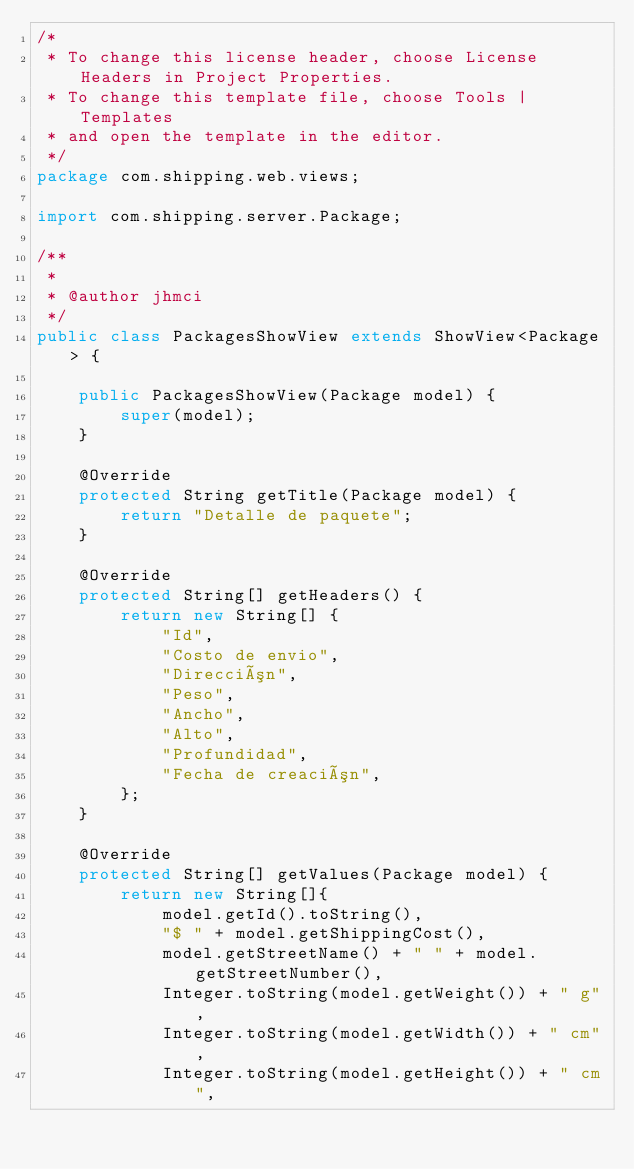<code> <loc_0><loc_0><loc_500><loc_500><_Java_>/*
 * To change this license header, choose License Headers in Project Properties.
 * To change this template file, choose Tools | Templates
 * and open the template in the editor.
 */
package com.shipping.web.views;

import com.shipping.server.Package; 

/**
 *
 * @author jhmci
 */
public class PackagesShowView extends ShowView<Package> {

    public PackagesShowView(Package model) {
        super(model);
    }

    @Override
    protected String getTitle(Package model) {
        return "Detalle de paquete";
    }

    @Override
    protected String[] getHeaders() {
        return new String[] {
            "Id",
            "Costo de envio",
            "Dirección",
            "Peso",
            "Ancho",
            "Alto",
            "Profundidad",
            "Fecha de creación",
        };
    }

    @Override
    protected String[] getValues(Package model) {
        return new String[]{
            model.getId().toString(),
            "$ " + model.getShippingCost(),
            model.getStreetName() + " " + model.getStreetNumber(),
            Integer.toString(model.getWeight()) + " g",
            Integer.toString(model.getWidth()) + " cm",
            Integer.toString(model.getHeight()) + " cm",</code> 